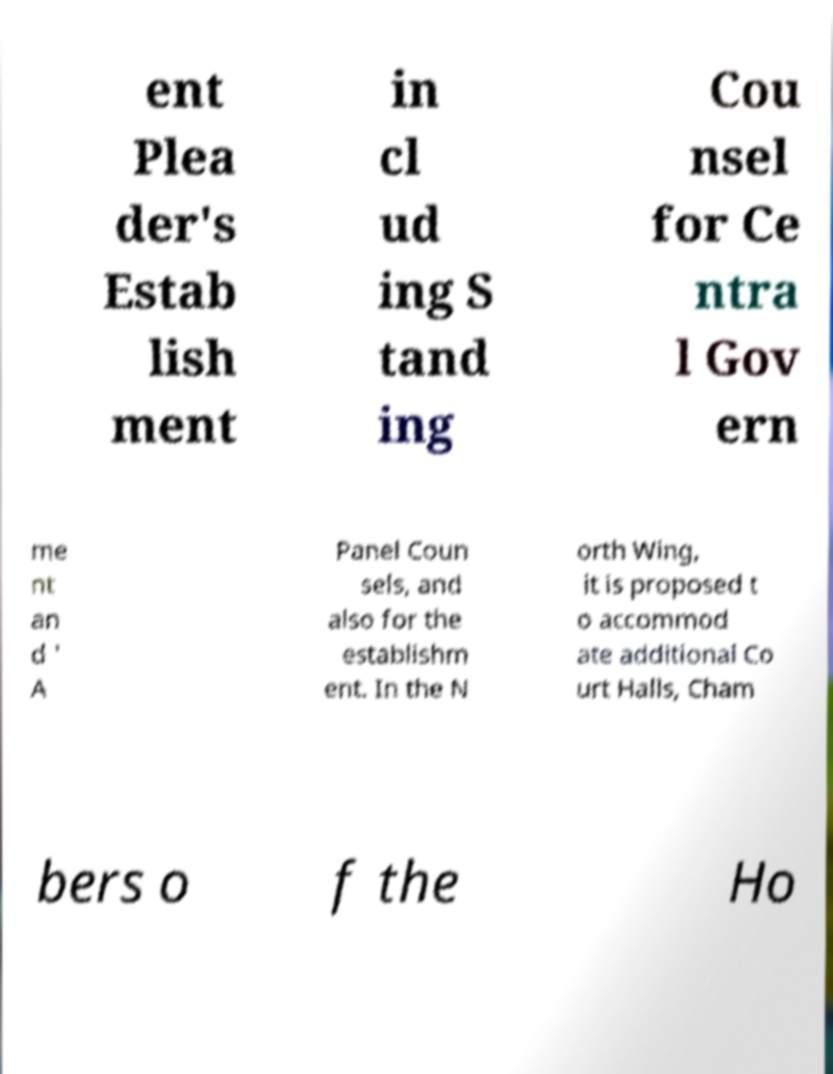Could you assist in decoding the text presented in this image and type it out clearly? ent Plea der's Estab lish ment in cl ud ing S tand ing Cou nsel for Ce ntra l Gov ern me nt an d ' A Panel Coun sels, and also for the establishm ent. In the N orth Wing, it is proposed t o accommod ate additional Co urt Halls, Cham bers o f the Ho 